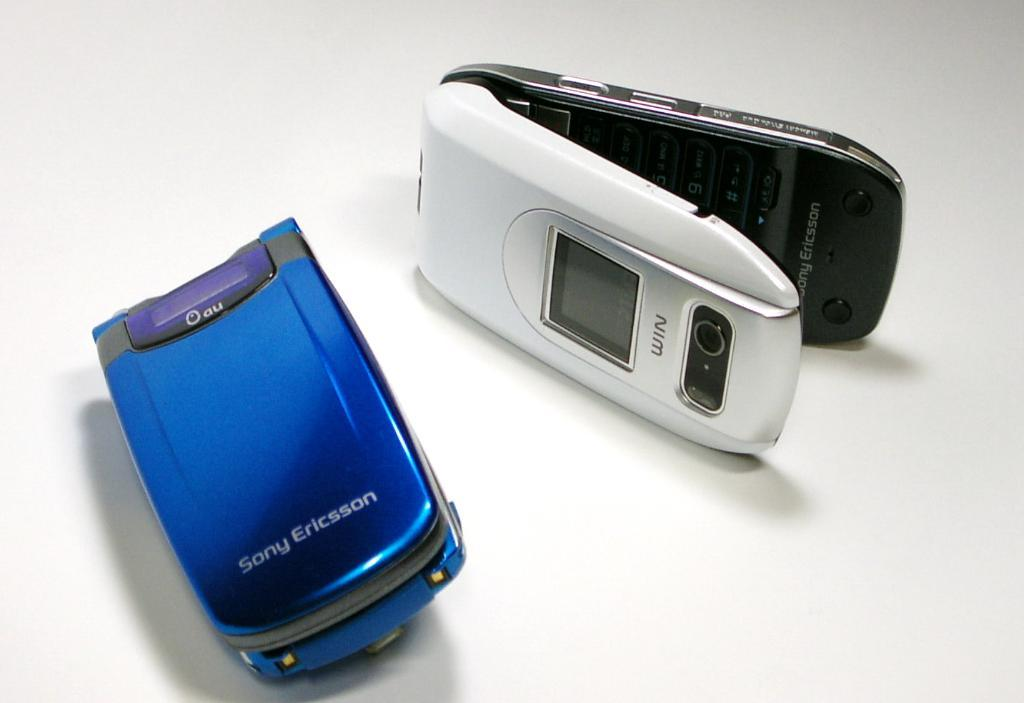<image>
Present a compact description of the photo's key features. A phone with the name Sony Ericsson on front 